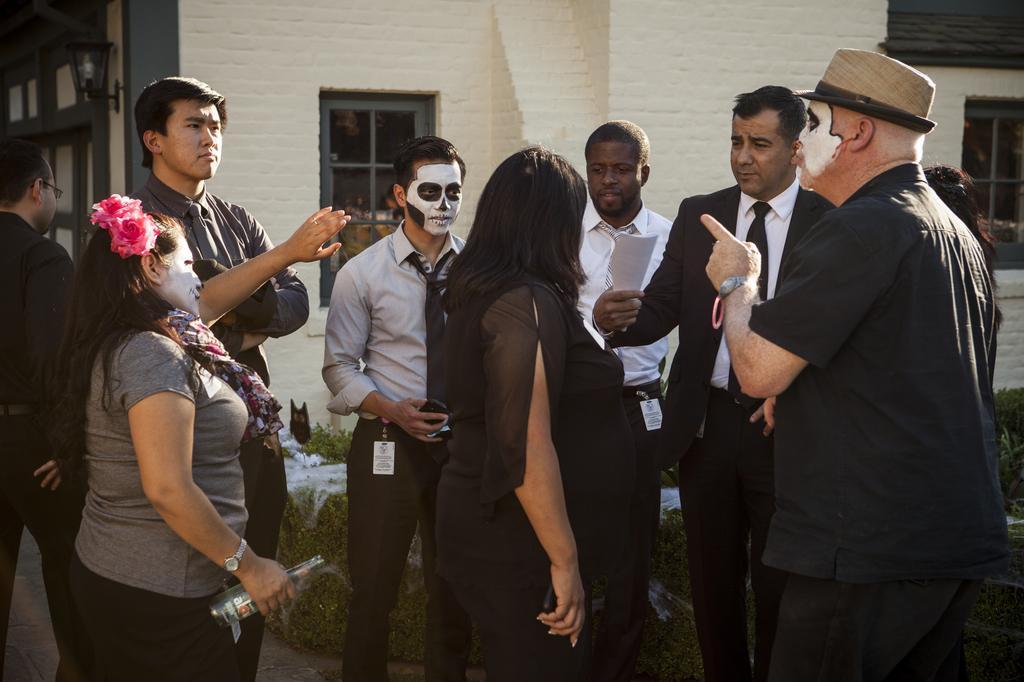In one or two sentences, can you explain what this image depicts? In this image there are group of people standing on the floor in which there are few people who are having a paint on their faces. In the background there is a building with the windows. On the ground there is grass. There is a woman on the left side who is holding the glass bottle. There is a man on the right side who is pointing the fingers in the middle. 